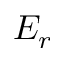Convert formula to latex. <formula><loc_0><loc_0><loc_500><loc_500>E _ { r }</formula> 